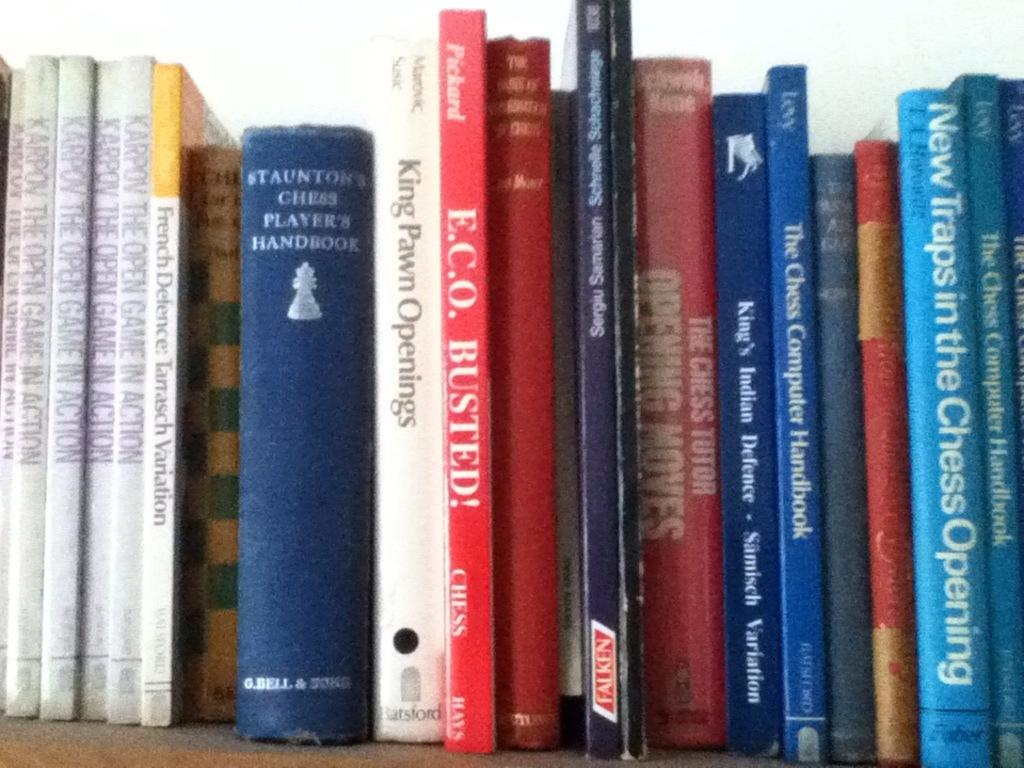Provide a one-sentence caption for the provided image. Several books about chess and how to play it are on a shelf. 